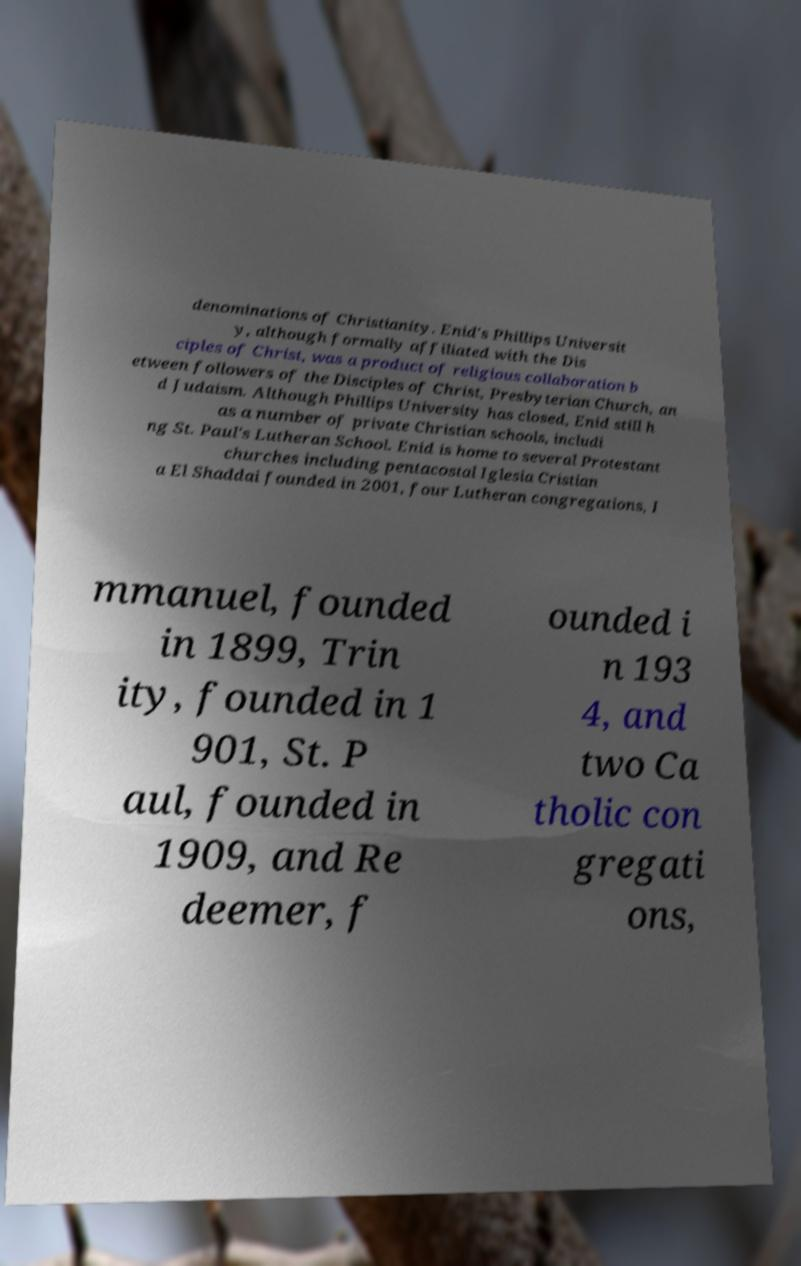I need the written content from this picture converted into text. Can you do that? denominations of Christianity. Enid's Phillips Universit y, although formally affiliated with the Dis ciples of Christ, was a product of religious collaboration b etween followers of the Disciples of Christ, Presbyterian Church, an d Judaism. Although Phillips University has closed, Enid still h as a number of private Christian schools, includi ng St. Paul's Lutheran School. Enid is home to several Protestant churches including pentacostal Iglesia Cristian a El Shaddai founded in 2001, four Lutheran congregations, I mmanuel, founded in 1899, Trin ity, founded in 1 901, St. P aul, founded in 1909, and Re deemer, f ounded i n 193 4, and two Ca tholic con gregati ons, 